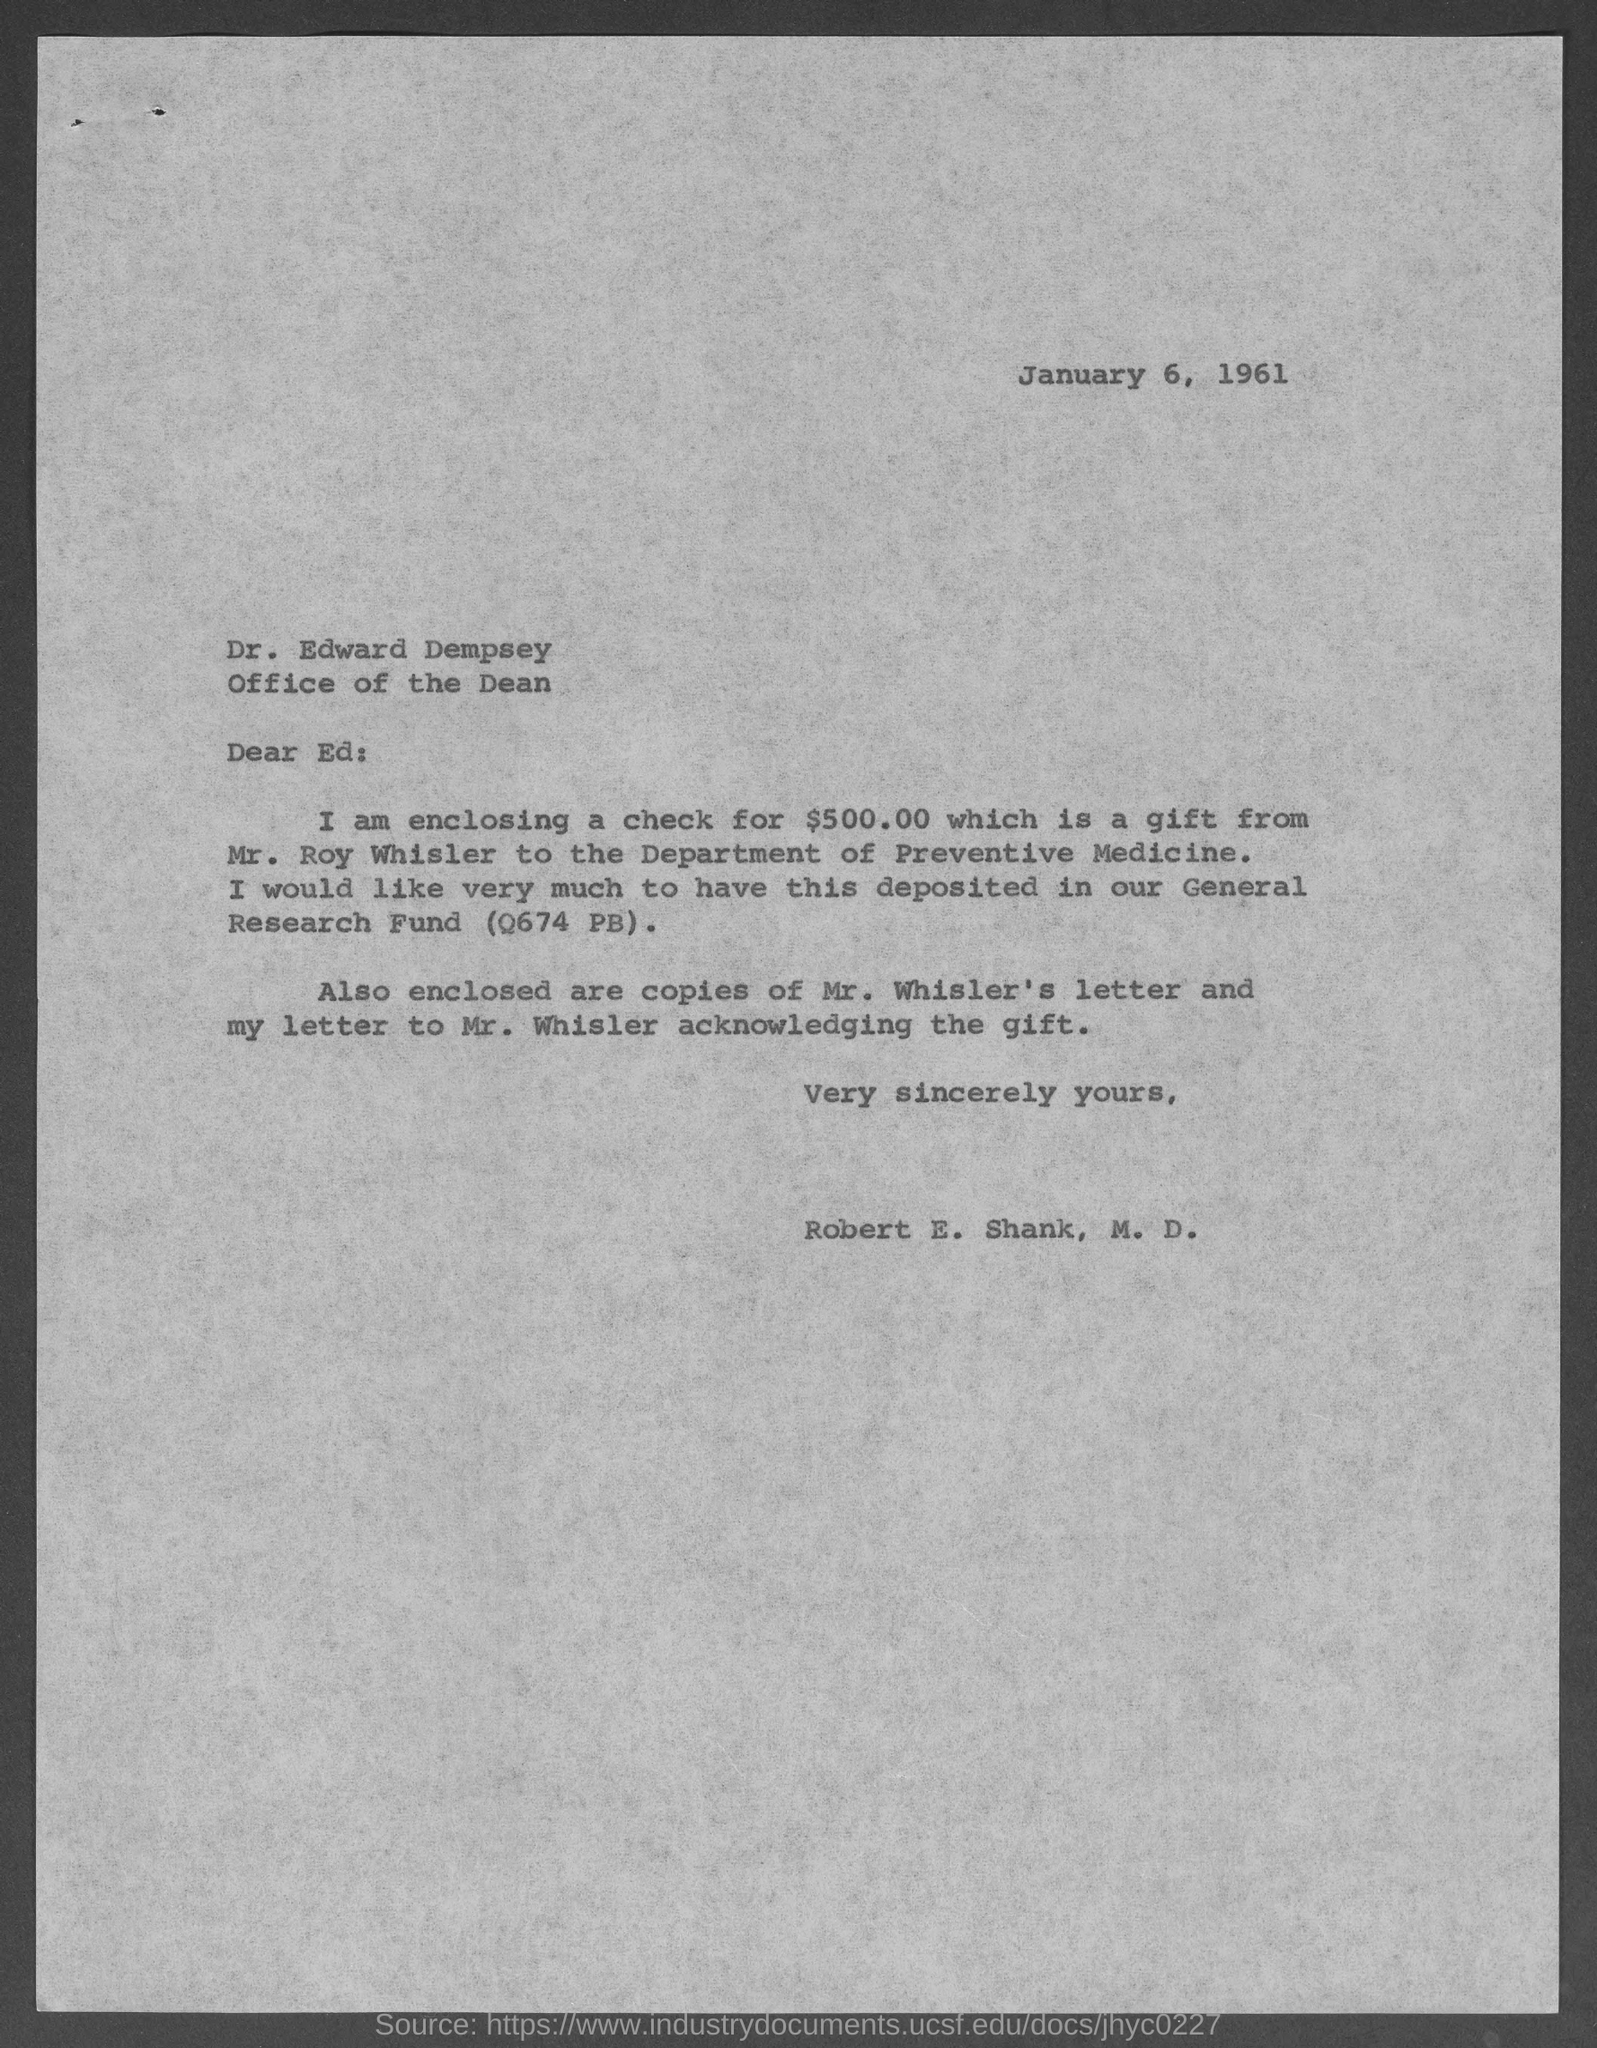Indicate a few pertinent items in this graphic. The amount of the check included is $500.00. The enclosed check for $500.00 is given to THE DEPARTMENT OF PREVENTIVE MEDICINE. The enclosed check for $500.00 is a gift from Mr. Roy Whisler. The date in question is January 6, 1961. 